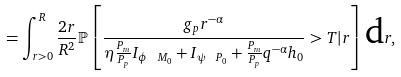<formula> <loc_0><loc_0><loc_500><loc_500>= \int _ { r > 0 } ^ { R } \frac { 2 r } { R ^ { 2 } } \mathbb { P } \left [ \frac { g _ { p } r ^ { - \alpha } } { \eta \frac { P _ { m } } { P _ { p } } I _ { \phi \ M _ { 0 } } + I _ { \psi \ P _ { 0 } } + \frac { P _ { m } } { P _ { p } } { q } ^ { - \alpha } { h _ { 0 } } } > T | r \right ] \text {d} r ,</formula> 